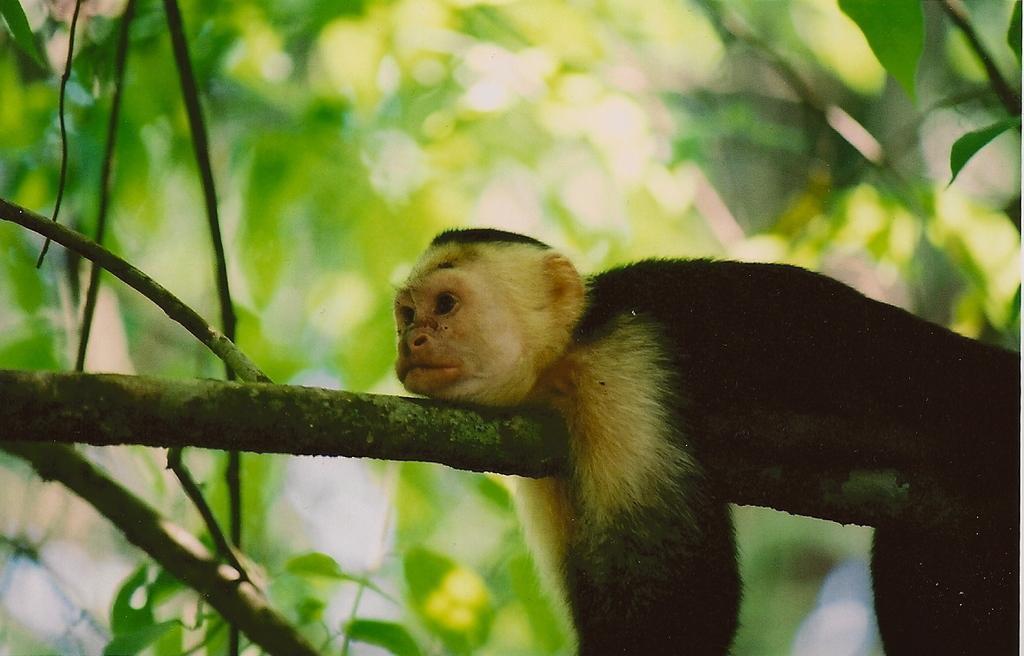In one or two sentences, can you explain what this image depicts? Background portion of the picture is blur. In this picture we can see an animal lying on a branch. We can see green leaves and few branches. 